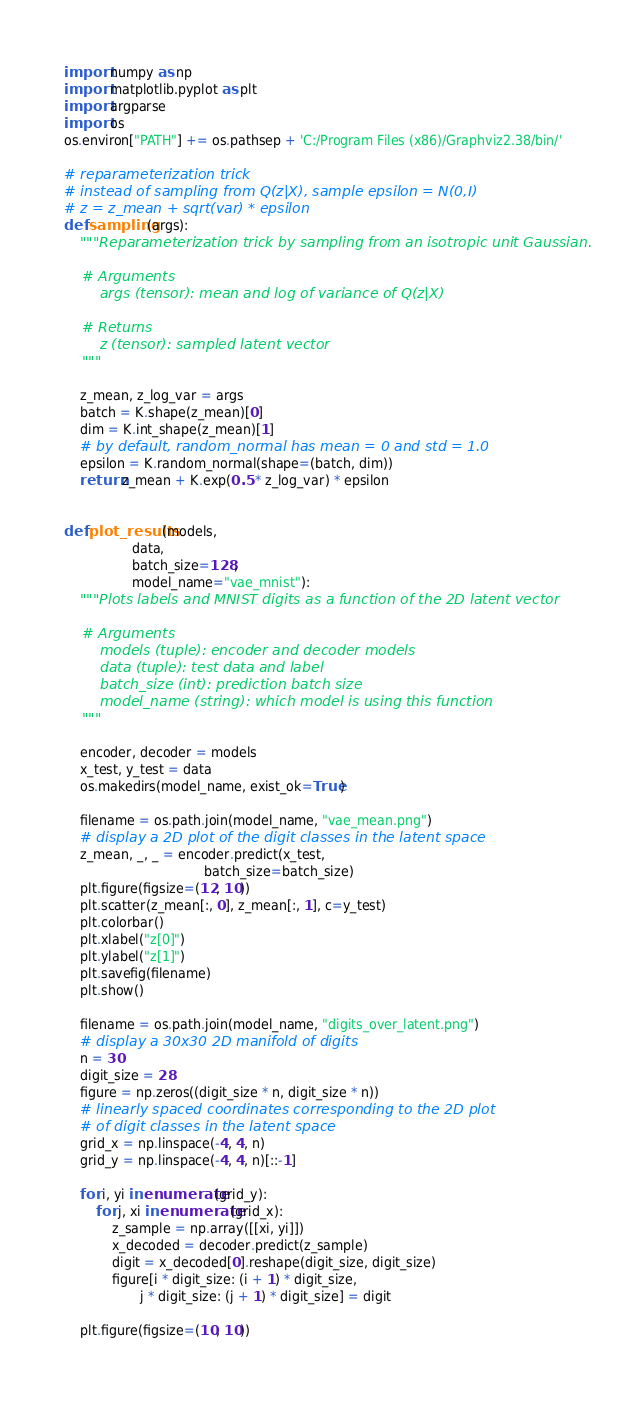Convert code to text. <code><loc_0><loc_0><loc_500><loc_500><_Python_>import numpy as np
import matplotlib.pyplot as plt
import argparse
import os
os.environ["PATH"] += os.pathsep + 'C:/Program Files (x86)/Graphviz2.38/bin/'

# reparameterization trick
# instead of sampling from Q(z|X), sample epsilon = N(0,I)
# z = z_mean + sqrt(var) * epsilon
def sampling(args):
    """Reparameterization trick by sampling from an isotropic unit Gaussian.

    # Arguments
        args (tensor): mean and log of variance of Q(z|X)

    # Returns
        z (tensor): sampled latent vector
    """

    z_mean, z_log_var = args
    batch = K.shape(z_mean)[0]
    dim = K.int_shape(z_mean)[1]
    # by default, random_normal has mean = 0 and std = 1.0
    epsilon = K.random_normal(shape=(batch, dim))
    return z_mean + K.exp(0.5 * z_log_var) * epsilon


def plot_results(models,
                 data,
                 batch_size=128,
                 model_name="vae_mnist"):
    """Plots labels and MNIST digits as a function of the 2D latent vector

    # Arguments
        models (tuple): encoder and decoder models
        data (tuple): test data and label
        batch_size (int): prediction batch size
        model_name (string): which model is using this function
    """

    encoder, decoder = models
    x_test, y_test = data
    os.makedirs(model_name, exist_ok=True)

    filename = os.path.join(model_name, "vae_mean.png")
    # display a 2D plot of the digit classes in the latent space
    z_mean, _, _ = encoder.predict(x_test,
                                   batch_size=batch_size)
    plt.figure(figsize=(12, 10))
    plt.scatter(z_mean[:, 0], z_mean[:, 1], c=y_test)
    plt.colorbar()
    plt.xlabel("z[0]")
    plt.ylabel("z[1]")
    plt.savefig(filename)
    plt.show()

    filename = os.path.join(model_name, "digits_over_latent.png")
    # display a 30x30 2D manifold of digits
    n = 30
    digit_size = 28
    figure = np.zeros((digit_size * n, digit_size * n))
    # linearly spaced coordinates corresponding to the 2D plot
    # of digit classes in the latent space
    grid_x = np.linspace(-4, 4, n)
    grid_y = np.linspace(-4, 4, n)[::-1]

    for i, yi in enumerate(grid_y):
        for j, xi in enumerate(grid_x):
            z_sample = np.array([[xi, yi]])
            x_decoded = decoder.predict(z_sample)
            digit = x_decoded[0].reshape(digit_size, digit_size)
            figure[i * digit_size: (i + 1) * digit_size,
                   j * digit_size: (j + 1) * digit_size] = digit

    plt.figure(figsize=(10, 10))</code> 